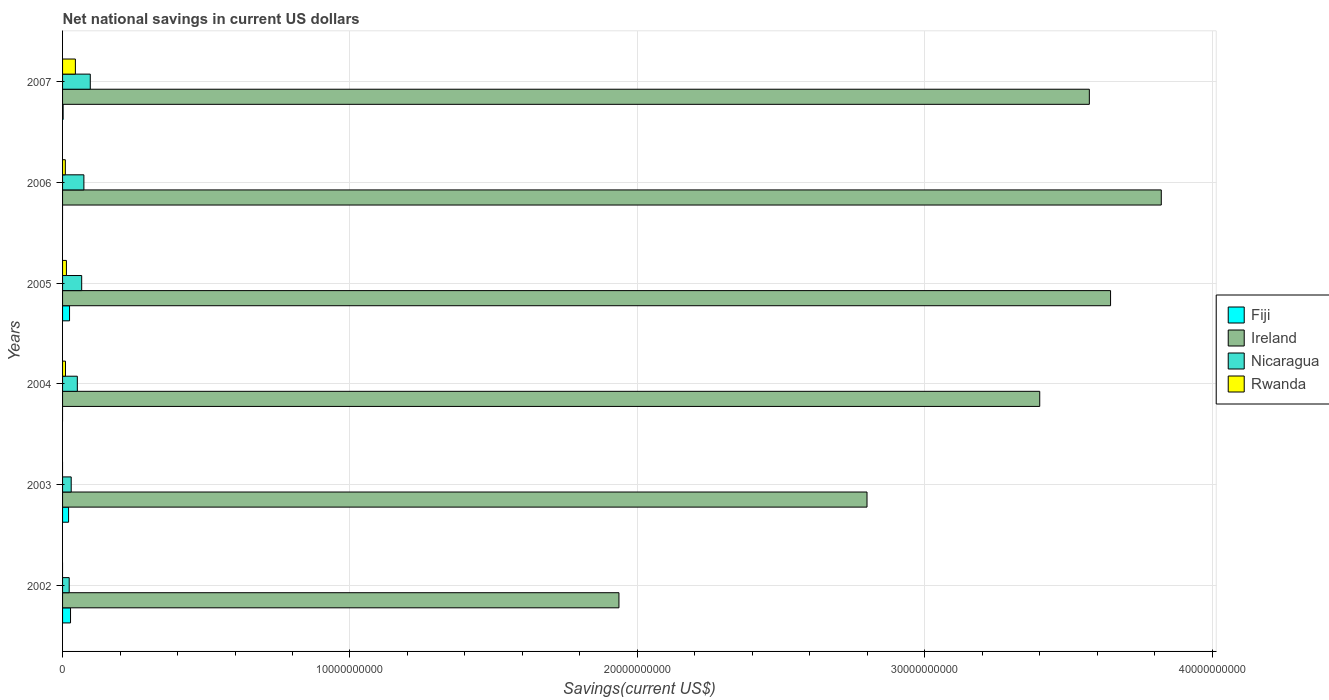How many different coloured bars are there?
Your answer should be compact. 4. How many groups of bars are there?
Give a very brief answer. 6. Are the number of bars per tick equal to the number of legend labels?
Your answer should be compact. No. Are the number of bars on each tick of the Y-axis equal?
Keep it short and to the point. No. What is the net national savings in Rwanda in 2006?
Offer a very short reply. 9.64e+07. Across all years, what is the maximum net national savings in Fiji?
Your answer should be very brief. 2.77e+08. Across all years, what is the minimum net national savings in Ireland?
Keep it short and to the point. 1.94e+1. In which year was the net national savings in Nicaragua maximum?
Provide a succinct answer. 2007. What is the total net national savings in Rwanda in the graph?
Ensure brevity in your answer.  7.78e+08. What is the difference between the net national savings in Nicaragua in 2002 and that in 2003?
Your response must be concise. -6.99e+07. What is the difference between the net national savings in Ireland in 2005 and the net national savings in Nicaragua in 2002?
Offer a terse response. 3.62e+1. What is the average net national savings in Fiji per year?
Give a very brief answer. 1.25e+08. In the year 2005, what is the difference between the net national savings in Nicaragua and net national savings in Fiji?
Make the answer very short. 4.22e+08. In how many years, is the net national savings in Rwanda greater than 38000000000 US$?
Your answer should be very brief. 0. What is the ratio of the net national savings in Nicaragua in 2003 to that in 2004?
Provide a short and direct response. 0.59. What is the difference between the highest and the second highest net national savings in Rwanda?
Your answer should be compact. 3.12e+08. What is the difference between the highest and the lowest net national savings in Ireland?
Your answer should be very brief. 1.89e+1. In how many years, is the net national savings in Rwanda greater than the average net national savings in Rwanda taken over all years?
Your answer should be very brief. 2. Is the sum of the net national savings in Rwanda in 2004 and 2006 greater than the maximum net national savings in Fiji across all years?
Provide a succinct answer. No. Is it the case that in every year, the sum of the net national savings in Rwanda and net national savings in Fiji is greater than the sum of net national savings in Nicaragua and net national savings in Ireland?
Provide a short and direct response. Yes. How many bars are there?
Keep it short and to the point. 20. Are all the bars in the graph horizontal?
Ensure brevity in your answer.  Yes. How many years are there in the graph?
Provide a succinct answer. 6. Are the values on the major ticks of X-axis written in scientific E-notation?
Provide a succinct answer. No. Where does the legend appear in the graph?
Your answer should be very brief. Center right. What is the title of the graph?
Keep it short and to the point. Net national savings in current US dollars. Does "Fragile and conflict affected situations" appear as one of the legend labels in the graph?
Give a very brief answer. No. What is the label or title of the X-axis?
Provide a short and direct response. Savings(current US$). What is the Savings(current US$) of Fiji in 2002?
Your answer should be very brief. 2.77e+08. What is the Savings(current US$) of Ireland in 2002?
Your response must be concise. 1.94e+1. What is the Savings(current US$) in Nicaragua in 2002?
Ensure brevity in your answer.  2.31e+08. What is the Savings(current US$) of Rwanda in 2002?
Provide a short and direct response. 0. What is the Savings(current US$) of Fiji in 2003?
Offer a very short reply. 2.09e+08. What is the Savings(current US$) of Ireland in 2003?
Provide a short and direct response. 2.80e+1. What is the Savings(current US$) in Nicaragua in 2003?
Make the answer very short. 3.01e+08. What is the Savings(current US$) of Ireland in 2004?
Provide a short and direct response. 3.40e+1. What is the Savings(current US$) in Nicaragua in 2004?
Ensure brevity in your answer.  5.14e+08. What is the Savings(current US$) of Rwanda in 2004?
Offer a very short reply. 1.01e+08. What is the Savings(current US$) of Fiji in 2005?
Offer a very short reply. 2.43e+08. What is the Savings(current US$) in Ireland in 2005?
Provide a short and direct response. 3.65e+1. What is the Savings(current US$) of Nicaragua in 2005?
Your answer should be compact. 6.65e+08. What is the Savings(current US$) in Rwanda in 2005?
Offer a terse response. 1.34e+08. What is the Savings(current US$) in Ireland in 2006?
Keep it short and to the point. 3.82e+1. What is the Savings(current US$) in Nicaragua in 2006?
Your answer should be compact. 7.42e+08. What is the Savings(current US$) of Rwanda in 2006?
Provide a succinct answer. 9.64e+07. What is the Savings(current US$) of Fiji in 2007?
Ensure brevity in your answer.  1.97e+07. What is the Savings(current US$) of Ireland in 2007?
Make the answer very short. 3.57e+1. What is the Savings(current US$) in Nicaragua in 2007?
Offer a very short reply. 9.64e+08. What is the Savings(current US$) in Rwanda in 2007?
Provide a succinct answer. 4.46e+08. Across all years, what is the maximum Savings(current US$) in Fiji?
Ensure brevity in your answer.  2.77e+08. Across all years, what is the maximum Savings(current US$) of Ireland?
Your answer should be compact. 3.82e+1. Across all years, what is the maximum Savings(current US$) in Nicaragua?
Make the answer very short. 9.64e+08. Across all years, what is the maximum Savings(current US$) in Rwanda?
Provide a succinct answer. 4.46e+08. Across all years, what is the minimum Savings(current US$) in Ireland?
Make the answer very short. 1.94e+1. Across all years, what is the minimum Savings(current US$) of Nicaragua?
Offer a very short reply. 2.31e+08. What is the total Savings(current US$) of Fiji in the graph?
Offer a very short reply. 7.49e+08. What is the total Savings(current US$) in Ireland in the graph?
Make the answer very short. 1.92e+11. What is the total Savings(current US$) of Nicaragua in the graph?
Ensure brevity in your answer.  3.42e+09. What is the total Savings(current US$) of Rwanda in the graph?
Ensure brevity in your answer.  7.78e+08. What is the difference between the Savings(current US$) in Fiji in 2002 and that in 2003?
Offer a very short reply. 6.84e+07. What is the difference between the Savings(current US$) of Ireland in 2002 and that in 2003?
Offer a terse response. -8.63e+09. What is the difference between the Savings(current US$) in Nicaragua in 2002 and that in 2003?
Offer a very short reply. -6.99e+07. What is the difference between the Savings(current US$) in Ireland in 2002 and that in 2004?
Your response must be concise. -1.46e+1. What is the difference between the Savings(current US$) in Nicaragua in 2002 and that in 2004?
Ensure brevity in your answer.  -2.83e+08. What is the difference between the Savings(current US$) in Fiji in 2002 and that in 2005?
Your response must be concise. 3.46e+07. What is the difference between the Savings(current US$) of Ireland in 2002 and that in 2005?
Ensure brevity in your answer.  -1.71e+1. What is the difference between the Savings(current US$) of Nicaragua in 2002 and that in 2005?
Give a very brief answer. -4.34e+08. What is the difference between the Savings(current US$) of Ireland in 2002 and that in 2006?
Make the answer very short. -1.89e+1. What is the difference between the Savings(current US$) in Nicaragua in 2002 and that in 2006?
Your answer should be very brief. -5.11e+08. What is the difference between the Savings(current US$) of Fiji in 2002 and that in 2007?
Provide a short and direct response. 2.58e+08. What is the difference between the Savings(current US$) in Ireland in 2002 and that in 2007?
Provide a short and direct response. -1.64e+1. What is the difference between the Savings(current US$) in Nicaragua in 2002 and that in 2007?
Your answer should be compact. -7.33e+08. What is the difference between the Savings(current US$) in Ireland in 2003 and that in 2004?
Give a very brief answer. -6.01e+09. What is the difference between the Savings(current US$) of Nicaragua in 2003 and that in 2004?
Your answer should be very brief. -2.13e+08. What is the difference between the Savings(current US$) in Fiji in 2003 and that in 2005?
Your answer should be compact. -3.38e+07. What is the difference between the Savings(current US$) of Ireland in 2003 and that in 2005?
Provide a succinct answer. -8.47e+09. What is the difference between the Savings(current US$) of Nicaragua in 2003 and that in 2005?
Offer a terse response. -3.64e+08. What is the difference between the Savings(current US$) of Ireland in 2003 and that in 2006?
Your response must be concise. -1.02e+1. What is the difference between the Savings(current US$) in Nicaragua in 2003 and that in 2006?
Ensure brevity in your answer.  -4.42e+08. What is the difference between the Savings(current US$) in Fiji in 2003 and that in 2007?
Make the answer very short. 1.89e+08. What is the difference between the Savings(current US$) in Ireland in 2003 and that in 2007?
Ensure brevity in your answer.  -7.74e+09. What is the difference between the Savings(current US$) of Nicaragua in 2003 and that in 2007?
Ensure brevity in your answer.  -6.64e+08. What is the difference between the Savings(current US$) in Ireland in 2004 and that in 2005?
Provide a short and direct response. -2.46e+09. What is the difference between the Savings(current US$) of Nicaragua in 2004 and that in 2005?
Your answer should be compact. -1.51e+08. What is the difference between the Savings(current US$) of Rwanda in 2004 and that in 2005?
Your answer should be compact. -3.28e+07. What is the difference between the Savings(current US$) in Ireland in 2004 and that in 2006?
Keep it short and to the point. -4.23e+09. What is the difference between the Savings(current US$) in Nicaragua in 2004 and that in 2006?
Give a very brief answer. -2.28e+08. What is the difference between the Savings(current US$) of Rwanda in 2004 and that in 2006?
Provide a short and direct response. 4.93e+06. What is the difference between the Savings(current US$) in Ireland in 2004 and that in 2007?
Your answer should be compact. -1.73e+09. What is the difference between the Savings(current US$) of Nicaragua in 2004 and that in 2007?
Offer a terse response. -4.50e+08. What is the difference between the Savings(current US$) in Rwanda in 2004 and that in 2007?
Offer a terse response. -3.45e+08. What is the difference between the Savings(current US$) of Ireland in 2005 and that in 2006?
Your answer should be very brief. -1.76e+09. What is the difference between the Savings(current US$) in Nicaragua in 2005 and that in 2006?
Your response must be concise. -7.71e+07. What is the difference between the Savings(current US$) of Rwanda in 2005 and that in 2006?
Ensure brevity in your answer.  3.77e+07. What is the difference between the Savings(current US$) of Fiji in 2005 and that in 2007?
Give a very brief answer. 2.23e+08. What is the difference between the Savings(current US$) of Ireland in 2005 and that in 2007?
Your answer should be compact. 7.39e+08. What is the difference between the Savings(current US$) in Nicaragua in 2005 and that in 2007?
Offer a terse response. -2.99e+08. What is the difference between the Savings(current US$) of Rwanda in 2005 and that in 2007?
Offer a terse response. -3.12e+08. What is the difference between the Savings(current US$) in Ireland in 2006 and that in 2007?
Provide a succinct answer. 2.50e+09. What is the difference between the Savings(current US$) in Nicaragua in 2006 and that in 2007?
Provide a succinct answer. -2.22e+08. What is the difference between the Savings(current US$) of Rwanda in 2006 and that in 2007?
Ensure brevity in your answer.  -3.50e+08. What is the difference between the Savings(current US$) in Fiji in 2002 and the Savings(current US$) in Ireland in 2003?
Provide a short and direct response. -2.77e+1. What is the difference between the Savings(current US$) in Fiji in 2002 and the Savings(current US$) in Nicaragua in 2003?
Your response must be concise. -2.33e+07. What is the difference between the Savings(current US$) in Ireland in 2002 and the Savings(current US$) in Nicaragua in 2003?
Offer a terse response. 1.91e+1. What is the difference between the Savings(current US$) in Fiji in 2002 and the Savings(current US$) in Ireland in 2004?
Provide a succinct answer. -3.37e+1. What is the difference between the Savings(current US$) in Fiji in 2002 and the Savings(current US$) in Nicaragua in 2004?
Ensure brevity in your answer.  -2.36e+08. What is the difference between the Savings(current US$) of Fiji in 2002 and the Savings(current US$) of Rwanda in 2004?
Your response must be concise. 1.76e+08. What is the difference between the Savings(current US$) of Ireland in 2002 and the Savings(current US$) of Nicaragua in 2004?
Give a very brief answer. 1.88e+1. What is the difference between the Savings(current US$) in Ireland in 2002 and the Savings(current US$) in Rwanda in 2004?
Your answer should be compact. 1.93e+1. What is the difference between the Savings(current US$) in Nicaragua in 2002 and the Savings(current US$) in Rwanda in 2004?
Offer a terse response. 1.30e+08. What is the difference between the Savings(current US$) in Fiji in 2002 and the Savings(current US$) in Ireland in 2005?
Ensure brevity in your answer.  -3.62e+1. What is the difference between the Savings(current US$) of Fiji in 2002 and the Savings(current US$) of Nicaragua in 2005?
Provide a succinct answer. -3.88e+08. What is the difference between the Savings(current US$) of Fiji in 2002 and the Savings(current US$) of Rwanda in 2005?
Offer a terse response. 1.43e+08. What is the difference between the Savings(current US$) in Ireland in 2002 and the Savings(current US$) in Nicaragua in 2005?
Your answer should be compact. 1.87e+1. What is the difference between the Savings(current US$) of Ireland in 2002 and the Savings(current US$) of Rwanda in 2005?
Ensure brevity in your answer.  1.92e+1. What is the difference between the Savings(current US$) in Nicaragua in 2002 and the Savings(current US$) in Rwanda in 2005?
Keep it short and to the point. 9.69e+07. What is the difference between the Savings(current US$) in Fiji in 2002 and the Savings(current US$) in Ireland in 2006?
Give a very brief answer. -3.80e+1. What is the difference between the Savings(current US$) of Fiji in 2002 and the Savings(current US$) of Nicaragua in 2006?
Offer a terse response. -4.65e+08. What is the difference between the Savings(current US$) of Fiji in 2002 and the Savings(current US$) of Rwanda in 2006?
Provide a succinct answer. 1.81e+08. What is the difference between the Savings(current US$) in Ireland in 2002 and the Savings(current US$) in Nicaragua in 2006?
Make the answer very short. 1.86e+1. What is the difference between the Savings(current US$) in Ireland in 2002 and the Savings(current US$) in Rwanda in 2006?
Provide a short and direct response. 1.93e+1. What is the difference between the Savings(current US$) of Nicaragua in 2002 and the Savings(current US$) of Rwanda in 2006?
Your answer should be compact. 1.35e+08. What is the difference between the Savings(current US$) of Fiji in 2002 and the Savings(current US$) of Ireland in 2007?
Ensure brevity in your answer.  -3.55e+1. What is the difference between the Savings(current US$) of Fiji in 2002 and the Savings(current US$) of Nicaragua in 2007?
Your response must be concise. -6.87e+08. What is the difference between the Savings(current US$) of Fiji in 2002 and the Savings(current US$) of Rwanda in 2007?
Ensure brevity in your answer.  -1.69e+08. What is the difference between the Savings(current US$) in Ireland in 2002 and the Savings(current US$) in Nicaragua in 2007?
Ensure brevity in your answer.  1.84e+1. What is the difference between the Savings(current US$) of Ireland in 2002 and the Savings(current US$) of Rwanda in 2007?
Provide a succinct answer. 1.89e+1. What is the difference between the Savings(current US$) of Nicaragua in 2002 and the Savings(current US$) of Rwanda in 2007?
Keep it short and to the point. -2.15e+08. What is the difference between the Savings(current US$) in Fiji in 2003 and the Savings(current US$) in Ireland in 2004?
Keep it short and to the point. -3.38e+1. What is the difference between the Savings(current US$) of Fiji in 2003 and the Savings(current US$) of Nicaragua in 2004?
Make the answer very short. -3.05e+08. What is the difference between the Savings(current US$) of Fiji in 2003 and the Savings(current US$) of Rwanda in 2004?
Provide a succinct answer. 1.08e+08. What is the difference between the Savings(current US$) in Ireland in 2003 and the Savings(current US$) in Nicaragua in 2004?
Provide a succinct answer. 2.75e+1. What is the difference between the Savings(current US$) of Ireland in 2003 and the Savings(current US$) of Rwanda in 2004?
Give a very brief answer. 2.79e+1. What is the difference between the Savings(current US$) of Nicaragua in 2003 and the Savings(current US$) of Rwanda in 2004?
Offer a terse response. 1.99e+08. What is the difference between the Savings(current US$) in Fiji in 2003 and the Savings(current US$) in Ireland in 2005?
Your answer should be compact. -3.63e+1. What is the difference between the Savings(current US$) of Fiji in 2003 and the Savings(current US$) of Nicaragua in 2005?
Make the answer very short. -4.56e+08. What is the difference between the Savings(current US$) of Fiji in 2003 and the Savings(current US$) of Rwanda in 2005?
Your answer should be compact. 7.50e+07. What is the difference between the Savings(current US$) of Ireland in 2003 and the Savings(current US$) of Nicaragua in 2005?
Offer a very short reply. 2.73e+1. What is the difference between the Savings(current US$) of Ireland in 2003 and the Savings(current US$) of Rwanda in 2005?
Provide a succinct answer. 2.79e+1. What is the difference between the Savings(current US$) of Nicaragua in 2003 and the Savings(current US$) of Rwanda in 2005?
Provide a short and direct response. 1.67e+08. What is the difference between the Savings(current US$) in Fiji in 2003 and the Savings(current US$) in Ireland in 2006?
Offer a very short reply. -3.80e+1. What is the difference between the Savings(current US$) in Fiji in 2003 and the Savings(current US$) in Nicaragua in 2006?
Your answer should be very brief. -5.33e+08. What is the difference between the Savings(current US$) in Fiji in 2003 and the Savings(current US$) in Rwanda in 2006?
Keep it short and to the point. 1.13e+08. What is the difference between the Savings(current US$) in Ireland in 2003 and the Savings(current US$) in Nicaragua in 2006?
Offer a very short reply. 2.72e+1. What is the difference between the Savings(current US$) of Ireland in 2003 and the Savings(current US$) of Rwanda in 2006?
Offer a terse response. 2.79e+1. What is the difference between the Savings(current US$) of Nicaragua in 2003 and the Savings(current US$) of Rwanda in 2006?
Offer a terse response. 2.04e+08. What is the difference between the Savings(current US$) in Fiji in 2003 and the Savings(current US$) in Ireland in 2007?
Your answer should be compact. -3.55e+1. What is the difference between the Savings(current US$) in Fiji in 2003 and the Savings(current US$) in Nicaragua in 2007?
Offer a very short reply. -7.55e+08. What is the difference between the Savings(current US$) of Fiji in 2003 and the Savings(current US$) of Rwanda in 2007?
Ensure brevity in your answer.  -2.37e+08. What is the difference between the Savings(current US$) in Ireland in 2003 and the Savings(current US$) in Nicaragua in 2007?
Your answer should be compact. 2.70e+1. What is the difference between the Savings(current US$) of Ireland in 2003 and the Savings(current US$) of Rwanda in 2007?
Ensure brevity in your answer.  2.75e+1. What is the difference between the Savings(current US$) of Nicaragua in 2003 and the Savings(current US$) of Rwanda in 2007?
Keep it short and to the point. -1.45e+08. What is the difference between the Savings(current US$) in Ireland in 2004 and the Savings(current US$) in Nicaragua in 2005?
Keep it short and to the point. 3.33e+1. What is the difference between the Savings(current US$) in Ireland in 2004 and the Savings(current US$) in Rwanda in 2005?
Your answer should be very brief. 3.39e+1. What is the difference between the Savings(current US$) of Nicaragua in 2004 and the Savings(current US$) of Rwanda in 2005?
Provide a short and direct response. 3.80e+08. What is the difference between the Savings(current US$) of Ireland in 2004 and the Savings(current US$) of Nicaragua in 2006?
Your response must be concise. 3.33e+1. What is the difference between the Savings(current US$) of Ireland in 2004 and the Savings(current US$) of Rwanda in 2006?
Your response must be concise. 3.39e+1. What is the difference between the Savings(current US$) of Nicaragua in 2004 and the Savings(current US$) of Rwanda in 2006?
Provide a short and direct response. 4.18e+08. What is the difference between the Savings(current US$) in Ireland in 2004 and the Savings(current US$) in Nicaragua in 2007?
Your answer should be compact. 3.30e+1. What is the difference between the Savings(current US$) in Ireland in 2004 and the Savings(current US$) in Rwanda in 2007?
Your answer should be compact. 3.36e+1. What is the difference between the Savings(current US$) in Nicaragua in 2004 and the Savings(current US$) in Rwanda in 2007?
Offer a terse response. 6.77e+07. What is the difference between the Savings(current US$) of Fiji in 2005 and the Savings(current US$) of Ireland in 2006?
Keep it short and to the point. -3.80e+1. What is the difference between the Savings(current US$) of Fiji in 2005 and the Savings(current US$) of Nicaragua in 2006?
Provide a short and direct response. -4.99e+08. What is the difference between the Savings(current US$) of Fiji in 2005 and the Savings(current US$) of Rwanda in 2006?
Make the answer very short. 1.46e+08. What is the difference between the Savings(current US$) in Ireland in 2005 and the Savings(current US$) in Nicaragua in 2006?
Provide a succinct answer. 3.57e+1. What is the difference between the Savings(current US$) of Ireland in 2005 and the Savings(current US$) of Rwanda in 2006?
Offer a terse response. 3.64e+1. What is the difference between the Savings(current US$) in Nicaragua in 2005 and the Savings(current US$) in Rwanda in 2006?
Your answer should be very brief. 5.69e+08. What is the difference between the Savings(current US$) of Fiji in 2005 and the Savings(current US$) of Ireland in 2007?
Give a very brief answer. -3.55e+1. What is the difference between the Savings(current US$) in Fiji in 2005 and the Savings(current US$) in Nicaragua in 2007?
Provide a short and direct response. -7.22e+08. What is the difference between the Savings(current US$) of Fiji in 2005 and the Savings(current US$) of Rwanda in 2007?
Ensure brevity in your answer.  -2.03e+08. What is the difference between the Savings(current US$) in Ireland in 2005 and the Savings(current US$) in Nicaragua in 2007?
Provide a short and direct response. 3.55e+1. What is the difference between the Savings(current US$) in Ireland in 2005 and the Savings(current US$) in Rwanda in 2007?
Ensure brevity in your answer.  3.60e+1. What is the difference between the Savings(current US$) of Nicaragua in 2005 and the Savings(current US$) of Rwanda in 2007?
Offer a very short reply. 2.19e+08. What is the difference between the Savings(current US$) of Ireland in 2006 and the Savings(current US$) of Nicaragua in 2007?
Provide a succinct answer. 3.73e+1. What is the difference between the Savings(current US$) of Ireland in 2006 and the Savings(current US$) of Rwanda in 2007?
Offer a terse response. 3.78e+1. What is the difference between the Savings(current US$) in Nicaragua in 2006 and the Savings(current US$) in Rwanda in 2007?
Your answer should be very brief. 2.96e+08. What is the average Savings(current US$) in Fiji per year?
Keep it short and to the point. 1.25e+08. What is the average Savings(current US$) of Ireland per year?
Your response must be concise. 3.20e+1. What is the average Savings(current US$) of Nicaragua per year?
Keep it short and to the point. 5.70e+08. What is the average Savings(current US$) in Rwanda per year?
Make the answer very short. 1.30e+08. In the year 2002, what is the difference between the Savings(current US$) of Fiji and Savings(current US$) of Ireland?
Make the answer very short. -1.91e+1. In the year 2002, what is the difference between the Savings(current US$) in Fiji and Savings(current US$) in Nicaragua?
Provide a succinct answer. 4.65e+07. In the year 2002, what is the difference between the Savings(current US$) of Ireland and Savings(current US$) of Nicaragua?
Your answer should be compact. 1.91e+1. In the year 2003, what is the difference between the Savings(current US$) in Fiji and Savings(current US$) in Ireland?
Provide a succinct answer. -2.78e+1. In the year 2003, what is the difference between the Savings(current US$) of Fiji and Savings(current US$) of Nicaragua?
Make the answer very short. -9.18e+07. In the year 2003, what is the difference between the Savings(current US$) of Ireland and Savings(current US$) of Nicaragua?
Provide a short and direct response. 2.77e+1. In the year 2004, what is the difference between the Savings(current US$) in Ireland and Savings(current US$) in Nicaragua?
Give a very brief answer. 3.35e+1. In the year 2004, what is the difference between the Savings(current US$) of Ireland and Savings(current US$) of Rwanda?
Your answer should be compact. 3.39e+1. In the year 2004, what is the difference between the Savings(current US$) of Nicaragua and Savings(current US$) of Rwanda?
Offer a very short reply. 4.13e+08. In the year 2005, what is the difference between the Savings(current US$) in Fiji and Savings(current US$) in Ireland?
Your answer should be very brief. -3.62e+1. In the year 2005, what is the difference between the Savings(current US$) in Fiji and Savings(current US$) in Nicaragua?
Your answer should be very brief. -4.22e+08. In the year 2005, what is the difference between the Savings(current US$) in Fiji and Savings(current US$) in Rwanda?
Give a very brief answer. 1.09e+08. In the year 2005, what is the difference between the Savings(current US$) of Ireland and Savings(current US$) of Nicaragua?
Ensure brevity in your answer.  3.58e+1. In the year 2005, what is the difference between the Savings(current US$) of Ireland and Savings(current US$) of Rwanda?
Offer a terse response. 3.63e+1. In the year 2005, what is the difference between the Savings(current US$) of Nicaragua and Savings(current US$) of Rwanda?
Provide a short and direct response. 5.31e+08. In the year 2006, what is the difference between the Savings(current US$) of Ireland and Savings(current US$) of Nicaragua?
Offer a very short reply. 3.75e+1. In the year 2006, what is the difference between the Savings(current US$) in Ireland and Savings(current US$) in Rwanda?
Provide a succinct answer. 3.81e+1. In the year 2006, what is the difference between the Savings(current US$) in Nicaragua and Savings(current US$) in Rwanda?
Give a very brief answer. 6.46e+08. In the year 2007, what is the difference between the Savings(current US$) in Fiji and Savings(current US$) in Ireland?
Offer a terse response. -3.57e+1. In the year 2007, what is the difference between the Savings(current US$) in Fiji and Savings(current US$) in Nicaragua?
Your answer should be very brief. -9.45e+08. In the year 2007, what is the difference between the Savings(current US$) of Fiji and Savings(current US$) of Rwanda?
Give a very brief answer. -4.27e+08. In the year 2007, what is the difference between the Savings(current US$) of Ireland and Savings(current US$) of Nicaragua?
Your answer should be very brief. 3.48e+1. In the year 2007, what is the difference between the Savings(current US$) in Ireland and Savings(current US$) in Rwanda?
Your answer should be compact. 3.53e+1. In the year 2007, what is the difference between the Savings(current US$) of Nicaragua and Savings(current US$) of Rwanda?
Provide a short and direct response. 5.18e+08. What is the ratio of the Savings(current US$) in Fiji in 2002 to that in 2003?
Give a very brief answer. 1.33. What is the ratio of the Savings(current US$) in Ireland in 2002 to that in 2003?
Ensure brevity in your answer.  0.69. What is the ratio of the Savings(current US$) in Nicaragua in 2002 to that in 2003?
Offer a very short reply. 0.77. What is the ratio of the Savings(current US$) of Ireland in 2002 to that in 2004?
Offer a terse response. 0.57. What is the ratio of the Savings(current US$) of Nicaragua in 2002 to that in 2004?
Offer a terse response. 0.45. What is the ratio of the Savings(current US$) in Fiji in 2002 to that in 2005?
Ensure brevity in your answer.  1.14. What is the ratio of the Savings(current US$) in Ireland in 2002 to that in 2005?
Provide a short and direct response. 0.53. What is the ratio of the Savings(current US$) in Nicaragua in 2002 to that in 2005?
Offer a very short reply. 0.35. What is the ratio of the Savings(current US$) of Ireland in 2002 to that in 2006?
Make the answer very short. 0.51. What is the ratio of the Savings(current US$) in Nicaragua in 2002 to that in 2006?
Offer a terse response. 0.31. What is the ratio of the Savings(current US$) of Fiji in 2002 to that in 2007?
Your response must be concise. 14.07. What is the ratio of the Savings(current US$) in Ireland in 2002 to that in 2007?
Your answer should be very brief. 0.54. What is the ratio of the Savings(current US$) of Nicaragua in 2002 to that in 2007?
Ensure brevity in your answer.  0.24. What is the ratio of the Savings(current US$) in Ireland in 2003 to that in 2004?
Give a very brief answer. 0.82. What is the ratio of the Savings(current US$) in Nicaragua in 2003 to that in 2004?
Your response must be concise. 0.59. What is the ratio of the Savings(current US$) in Fiji in 2003 to that in 2005?
Ensure brevity in your answer.  0.86. What is the ratio of the Savings(current US$) in Ireland in 2003 to that in 2005?
Your answer should be compact. 0.77. What is the ratio of the Savings(current US$) of Nicaragua in 2003 to that in 2005?
Ensure brevity in your answer.  0.45. What is the ratio of the Savings(current US$) of Ireland in 2003 to that in 2006?
Your response must be concise. 0.73. What is the ratio of the Savings(current US$) in Nicaragua in 2003 to that in 2006?
Make the answer very short. 0.41. What is the ratio of the Savings(current US$) in Fiji in 2003 to that in 2007?
Offer a terse response. 10.6. What is the ratio of the Savings(current US$) of Ireland in 2003 to that in 2007?
Offer a very short reply. 0.78. What is the ratio of the Savings(current US$) in Nicaragua in 2003 to that in 2007?
Offer a terse response. 0.31. What is the ratio of the Savings(current US$) in Ireland in 2004 to that in 2005?
Provide a succinct answer. 0.93. What is the ratio of the Savings(current US$) of Nicaragua in 2004 to that in 2005?
Provide a short and direct response. 0.77. What is the ratio of the Savings(current US$) of Rwanda in 2004 to that in 2005?
Provide a short and direct response. 0.76. What is the ratio of the Savings(current US$) in Ireland in 2004 to that in 2006?
Offer a terse response. 0.89. What is the ratio of the Savings(current US$) of Nicaragua in 2004 to that in 2006?
Give a very brief answer. 0.69. What is the ratio of the Savings(current US$) in Rwanda in 2004 to that in 2006?
Your response must be concise. 1.05. What is the ratio of the Savings(current US$) in Ireland in 2004 to that in 2007?
Offer a very short reply. 0.95. What is the ratio of the Savings(current US$) in Nicaragua in 2004 to that in 2007?
Give a very brief answer. 0.53. What is the ratio of the Savings(current US$) in Rwanda in 2004 to that in 2007?
Your response must be concise. 0.23. What is the ratio of the Savings(current US$) in Ireland in 2005 to that in 2006?
Give a very brief answer. 0.95. What is the ratio of the Savings(current US$) of Nicaragua in 2005 to that in 2006?
Your answer should be compact. 0.9. What is the ratio of the Savings(current US$) in Rwanda in 2005 to that in 2006?
Provide a succinct answer. 1.39. What is the ratio of the Savings(current US$) of Fiji in 2005 to that in 2007?
Your response must be concise. 12.32. What is the ratio of the Savings(current US$) in Ireland in 2005 to that in 2007?
Your response must be concise. 1.02. What is the ratio of the Savings(current US$) in Nicaragua in 2005 to that in 2007?
Your answer should be very brief. 0.69. What is the ratio of the Savings(current US$) in Rwanda in 2005 to that in 2007?
Provide a short and direct response. 0.3. What is the ratio of the Savings(current US$) of Ireland in 2006 to that in 2007?
Ensure brevity in your answer.  1.07. What is the ratio of the Savings(current US$) of Nicaragua in 2006 to that in 2007?
Offer a terse response. 0.77. What is the ratio of the Savings(current US$) in Rwanda in 2006 to that in 2007?
Offer a terse response. 0.22. What is the difference between the highest and the second highest Savings(current US$) in Fiji?
Your answer should be compact. 3.46e+07. What is the difference between the highest and the second highest Savings(current US$) in Ireland?
Offer a terse response. 1.76e+09. What is the difference between the highest and the second highest Savings(current US$) of Nicaragua?
Provide a short and direct response. 2.22e+08. What is the difference between the highest and the second highest Savings(current US$) in Rwanda?
Provide a short and direct response. 3.12e+08. What is the difference between the highest and the lowest Savings(current US$) of Fiji?
Keep it short and to the point. 2.77e+08. What is the difference between the highest and the lowest Savings(current US$) in Ireland?
Your response must be concise. 1.89e+1. What is the difference between the highest and the lowest Savings(current US$) of Nicaragua?
Provide a succinct answer. 7.33e+08. What is the difference between the highest and the lowest Savings(current US$) in Rwanda?
Your answer should be compact. 4.46e+08. 